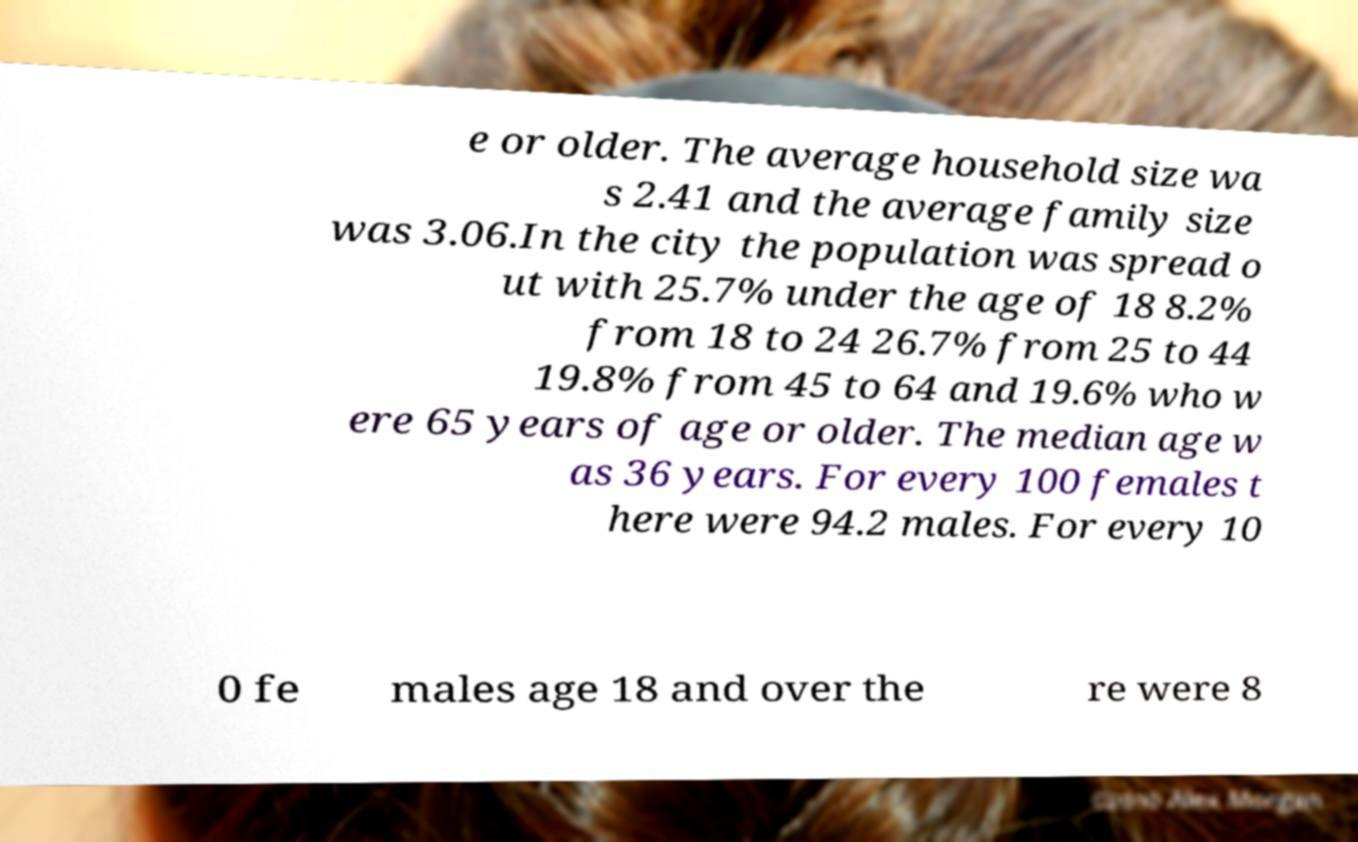Please identify and transcribe the text found in this image. e or older. The average household size wa s 2.41 and the average family size was 3.06.In the city the population was spread o ut with 25.7% under the age of 18 8.2% from 18 to 24 26.7% from 25 to 44 19.8% from 45 to 64 and 19.6% who w ere 65 years of age or older. The median age w as 36 years. For every 100 females t here were 94.2 males. For every 10 0 fe males age 18 and over the re were 8 